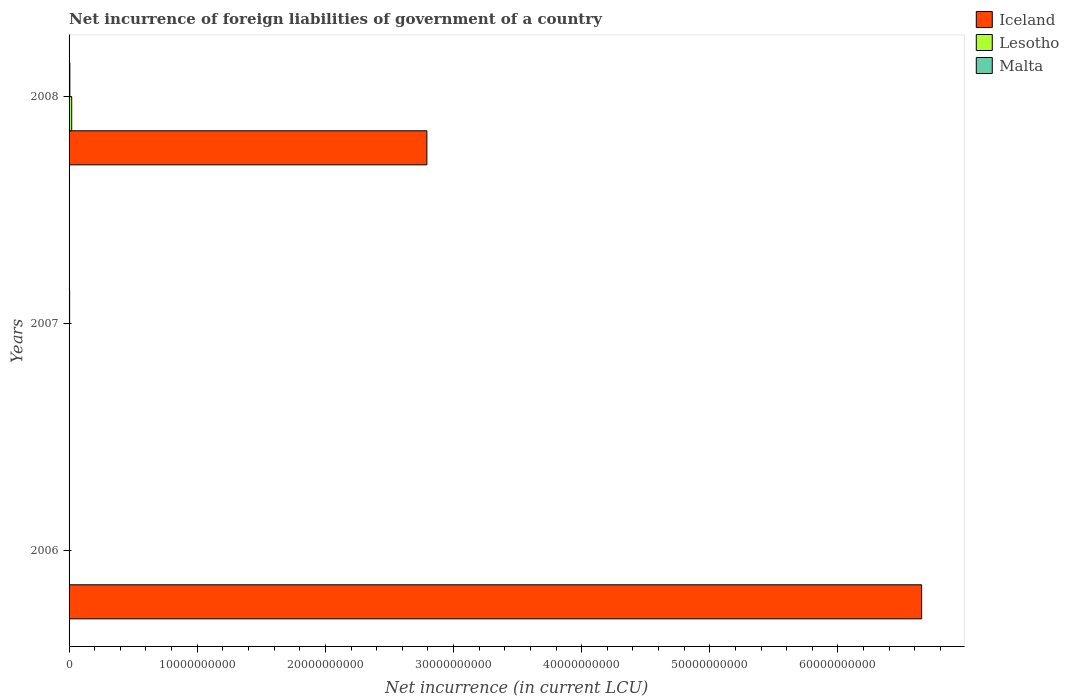How many different coloured bars are there?
Your answer should be very brief. 3. Are the number of bars per tick equal to the number of legend labels?
Keep it short and to the point. No. How many bars are there on the 3rd tick from the top?
Your answer should be compact. 1. How many bars are there on the 3rd tick from the bottom?
Make the answer very short. 3. What is the label of the 1st group of bars from the top?
Offer a very short reply. 2008. What is the net incurrence of foreign liabilities in Lesotho in 2008?
Provide a succinct answer. 2.05e+08. Across all years, what is the maximum net incurrence of foreign liabilities in Iceland?
Ensure brevity in your answer.  6.65e+1. In which year was the net incurrence of foreign liabilities in Iceland maximum?
Ensure brevity in your answer.  2006. What is the total net incurrence of foreign liabilities in Malta in the graph?
Give a very brief answer. 1.04e+08. What is the difference between the net incurrence of foreign liabilities in Malta in 2007 and that in 2008?
Offer a very short reply. -1.75e+07. What is the difference between the net incurrence of foreign liabilities in Iceland in 2008 and the net incurrence of foreign liabilities in Lesotho in 2007?
Your response must be concise. 2.79e+1. What is the average net incurrence of foreign liabilities in Malta per year?
Provide a short and direct response. 3.47e+07. In the year 2008, what is the difference between the net incurrence of foreign liabilities in Lesotho and net incurrence of foreign liabilities in Iceland?
Offer a terse response. -2.77e+1. What is the ratio of the net incurrence of foreign liabilities in Malta in 2007 to that in 2008?
Make the answer very short. 0.71. What is the difference between the highest and the lowest net incurrence of foreign liabilities in Iceland?
Offer a terse response. 6.65e+1. In how many years, is the net incurrence of foreign liabilities in Iceland greater than the average net incurrence of foreign liabilities in Iceland taken over all years?
Ensure brevity in your answer.  1. Is it the case that in every year, the sum of the net incurrence of foreign liabilities in Lesotho and net incurrence of foreign liabilities in Iceland is greater than the net incurrence of foreign liabilities in Malta?
Your answer should be compact. No. How many years are there in the graph?
Keep it short and to the point. 3. Are the values on the major ticks of X-axis written in scientific E-notation?
Your answer should be compact. No. Does the graph contain any zero values?
Your answer should be compact. Yes. How many legend labels are there?
Your answer should be very brief. 3. What is the title of the graph?
Provide a short and direct response. Net incurrence of foreign liabilities of government of a country. Does "Comoros" appear as one of the legend labels in the graph?
Keep it short and to the point. No. What is the label or title of the X-axis?
Offer a terse response. Net incurrence (in current LCU). What is the Net incurrence (in current LCU) of Iceland in 2006?
Offer a very short reply. 6.65e+1. What is the Net incurrence (in current LCU) in Lesotho in 2006?
Make the answer very short. 0. What is the Net incurrence (in current LCU) of Malta in 2007?
Give a very brief answer. 4.33e+07. What is the Net incurrence (in current LCU) in Iceland in 2008?
Your answer should be compact. 2.79e+1. What is the Net incurrence (in current LCU) in Lesotho in 2008?
Offer a terse response. 2.05e+08. What is the Net incurrence (in current LCU) in Malta in 2008?
Offer a very short reply. 6.08e+07. Across all years, what is the maximum Net incurrence (in current LCU) of Iceland?
Offer a terse response. 6.65e+1. Across all years, what is the maximum Net incurrence (in current LCU) of Lesotho?
Your answer should be very brief. 2.05e+08. Across all years, what is the maximum Net incurrence (in current LCU) in Malta?
Keep it short and to the point. 6.08e+07. Across all years, what is the minimum Net incurrence (in current LCU) in Malta?
Your answer should be compact. 0. What is the total Net incurrence (in current LCU) in Iceland in the graph?
Ensure brevity in your answer.  9.44e+1. What is the total Net incurrence (in current LCU) in Lesotho in the graph?
Provide a short and direct response. 2.05e+08. What is the total Net incurrence (in current LCU) of Malta in the graph?
Provide a succinct answer. 1.04e+08. What is the difference between the Net incurrence (in current LCU) of Iceland in 2006 and that in 2008?
Your response must be concise. 3.86e+1. What is the difference between the Net incurrence (in current LCU) in Malta in 2007 and that in 2008?
Give a very brief answer. -1.75e+07. What is the difference between the Net incurrence (in current LCU) of Iceland in 2006 and the Net incurrence (in current LCU) of Malta in 2007?
Give a very brief answer. 6.65e+1. What is the difference between the Net incurrence (in current LCU) of Iceland in 2006 and the Net incurrence (in current LCU) of Lesotho in 2008?
Your response must be concise. 6.63e+1. What is the difference between the Net incurrence (in current LCU) in Iceland in 2006 and the Net incurrence (in current LCU) in Malta in 2008?
Provide a succinct answer. 6.65e+1. What is the average Net incurrence (in current LCU) in Iceland per year?
Offer a very short reply. 3.15e+1. What is the average Net incurrence (in current LCU) of Lesotho per year?
Offer a terse response. 6.84e+07. What is the average Net incurrence (in current LCU) of Malta per year?
Make the answer very short. 3.47e+07. In the year 2008, what is the difference between the Net incurrence (in current LCU) of Iceland and Net incurrence (in current LCU) of Lesotho?
Offer a terse response. 2.77e+1. In the year 2008, what is the difference between the Net incurrence (in current LCU) of Iceland and Net incurrence (in current LCU) of Malta?
Give a very brief answer. 2.79e+1. In the year 2008, what is the difference between the Net incurrence (in current LCU) in Lesotho and Net incurrence (in current LCU) in Malta?
Keep it short and to the point. 1.44e+08. What is the ratio of the Net incurrence (in current LCU) of Iceland in 2006 to that in 2008?
Keep it short and to the point. 2.38. What is the ratio of the Net incurrence (in current LCU) in Malta in 2007 to that in 2008?
Provide a short and direct response. 0.71. What is the difference between the highest and the lowest Net incurrence (in current LCU) of Iceland?
Make the answer very short. 6.65e+1. What is the difference between the highest and the lowest Net incurrence (in current LCU) in Lesotho?
Your answer should be very brief. 2.05e+08. What is the difference between the highest and the lowest Net incurrence (in current LCU) in Malta?
Offer a terse response. 6.08e+07. 